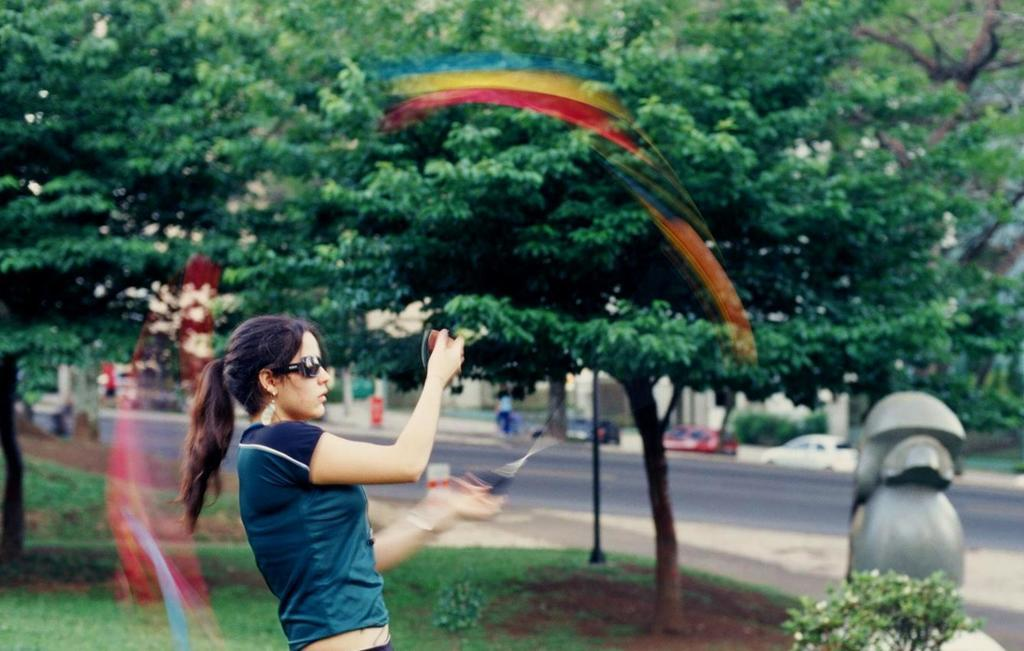What is the main subject in the image? There is a person in the image. What can be seen in the background of the image? There are trees, plants, grass, a pole, vehicles, people, a road, and other unspecified objects in the background of the image. What type of vegetable is being harvested by the laborer in the image? There is no laborer or vegetable present in the image. 